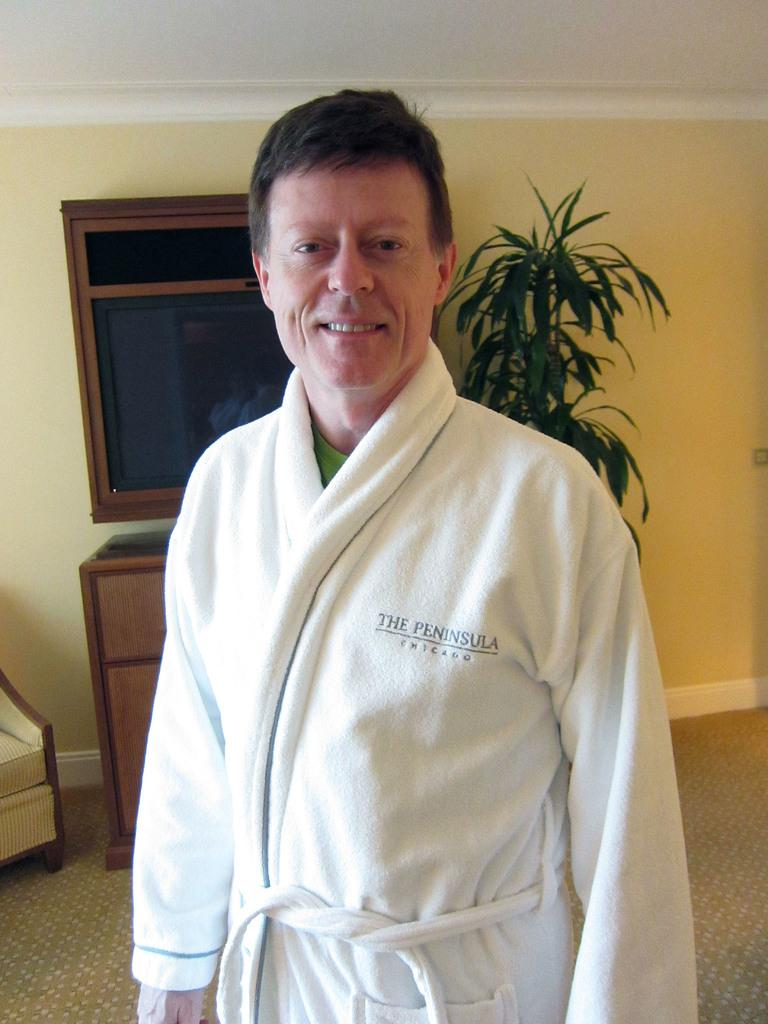Provide a one-sentence caption for the provided image. A man wearing a robe with The Peninsula Chicago on it. 